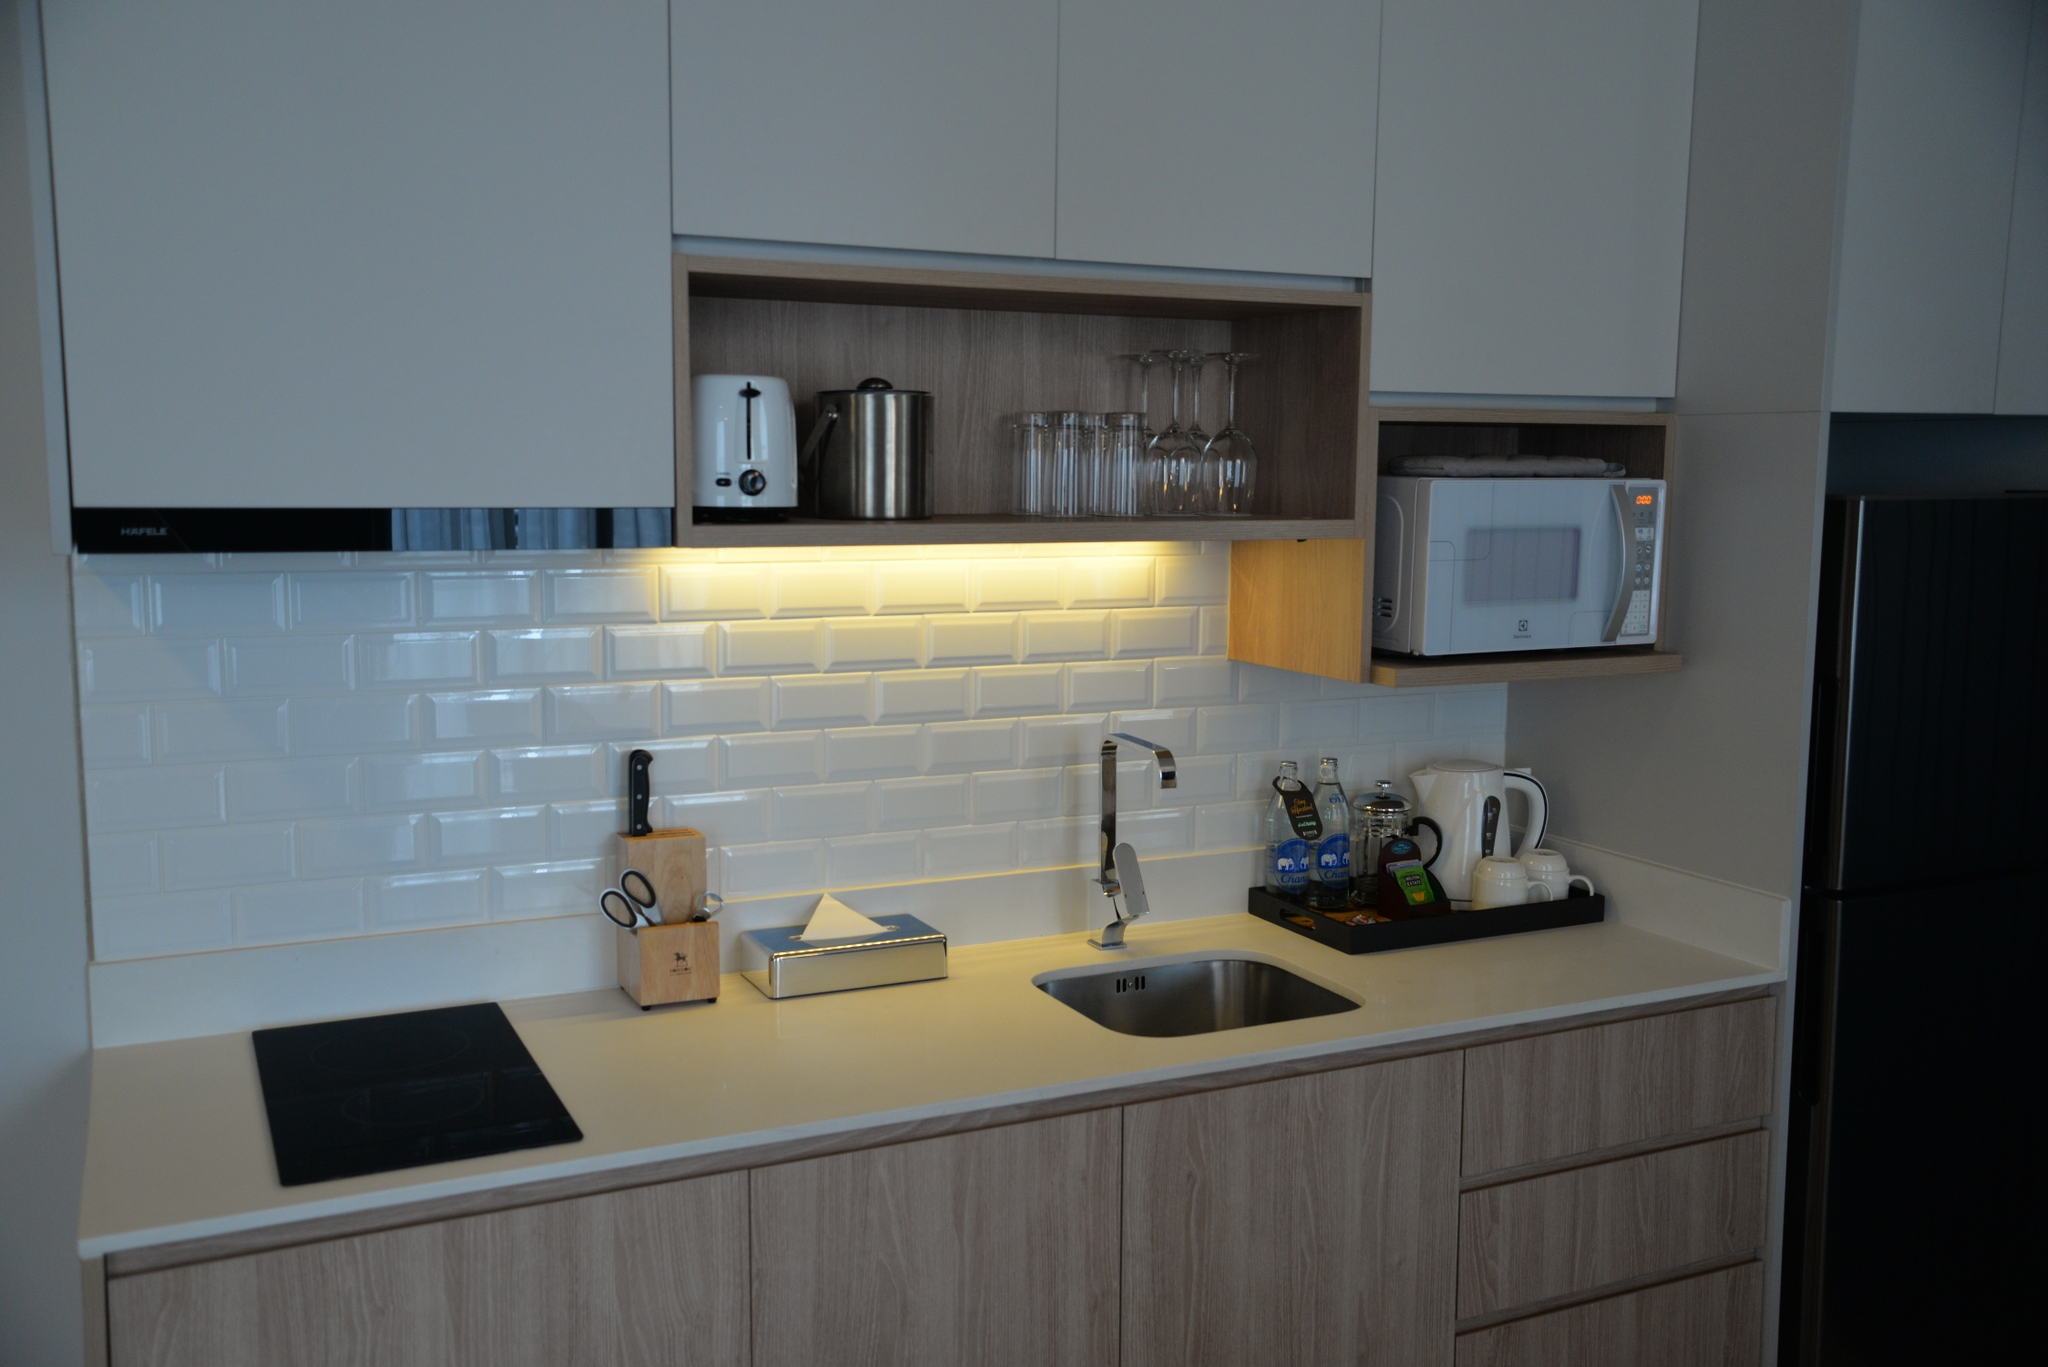What is this photo about? The image depicts a sleek and modern kitchen space illuminated by ample natural light. The neutral color palette features wooden cabinetry complemented by a glossy white subway tile backsplash, which adds a touch of elegance. On the pristine light-gray countertop, there is a black induction cooktop and a stainless steel sink, showcasing the kitchen's contemporary functionalities. Small appliances such as a coffee maker, kettle, and toaster are meticulously arranged, ready for use. The cabinets include sections with glass doors, beautifully displaying glassware while providing substantial storage. Integrated on the right are a microwave and refrigerator that blend seamlessly with the kitchen's design. A large window above the sink enhances the room's natural brightness, creating a warm and inviting atmosphere. 